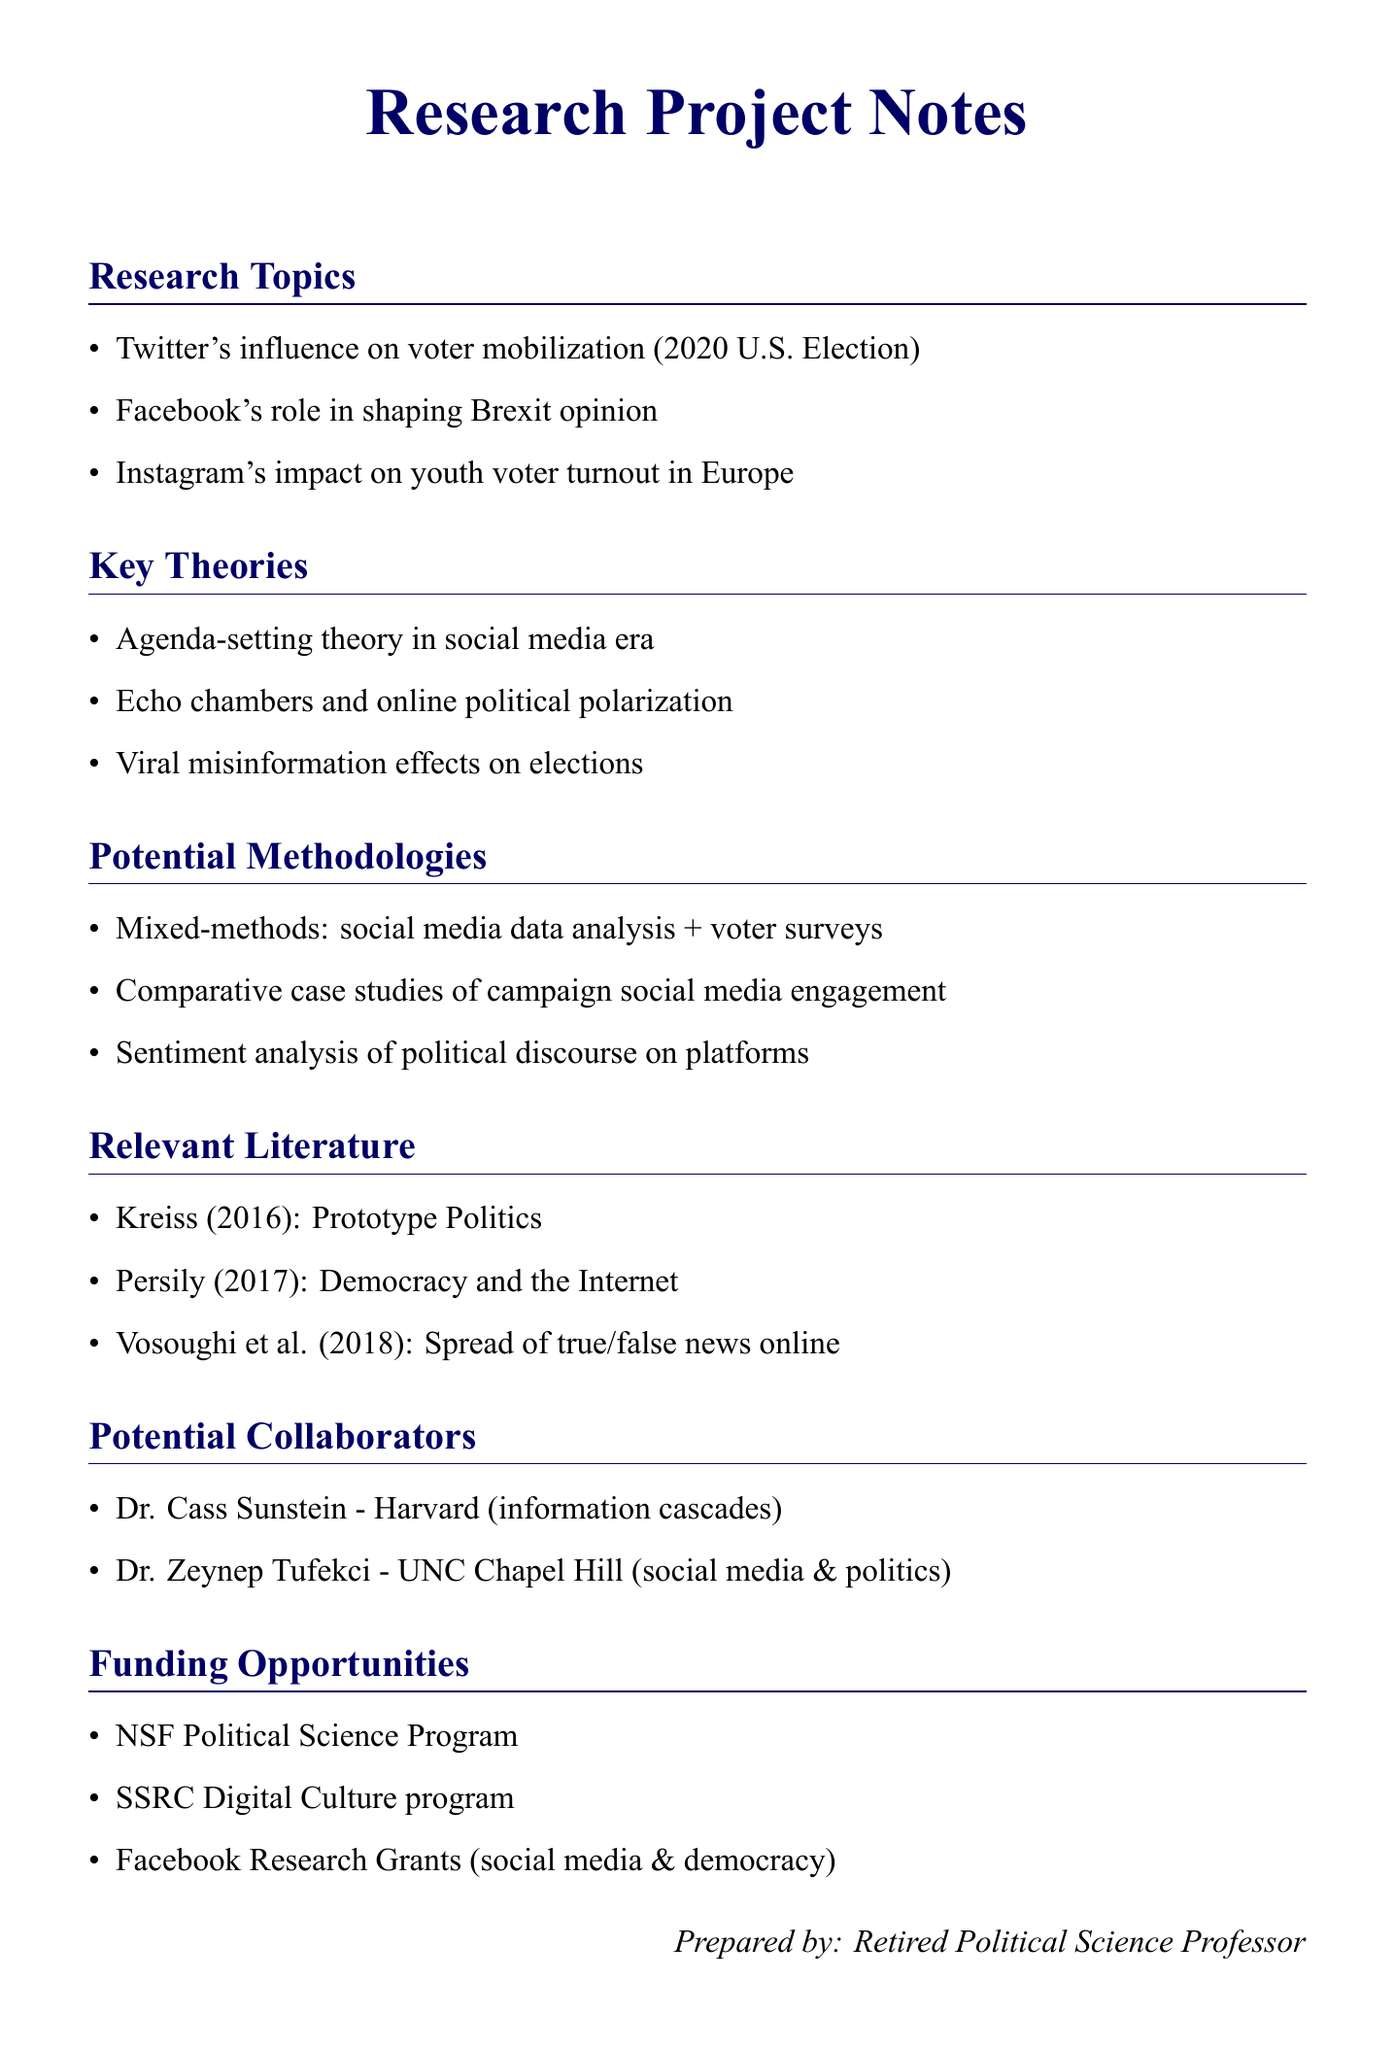What is one research topic listed? The document lists various research topics related to social media and political campaigns, an example being the influence of Twitter on voter mobilization during the 2020 U.S. Presidential Election.
Answer: Twitter's influence on voter mobilization (2020 U.S. Election) Which theory addresses online political polarization? The document mentions key theories, including the idea that echo chambers contribute to political polarization in the online context.
Answer: Echo chambers and online political polarization What methodology combines social media data analysis and voter surveys? The document outlines potential methodologies, specifically highlighting a mixed-methods approach that merges social media data and surveys.
Answer: Mixed-methods: social media data analysis + voter surveys Who is a potential collaborator from Harvard? The potential collaborators section provides names and their affiliations, including Dr. Cass Sunstein from Harvard Law School.
Answer: Dr. Cass Sunstein How many funding opportunities are listed? The document outlines specific funding opportunities available for the research project, totaling three options.
Answer: 3 